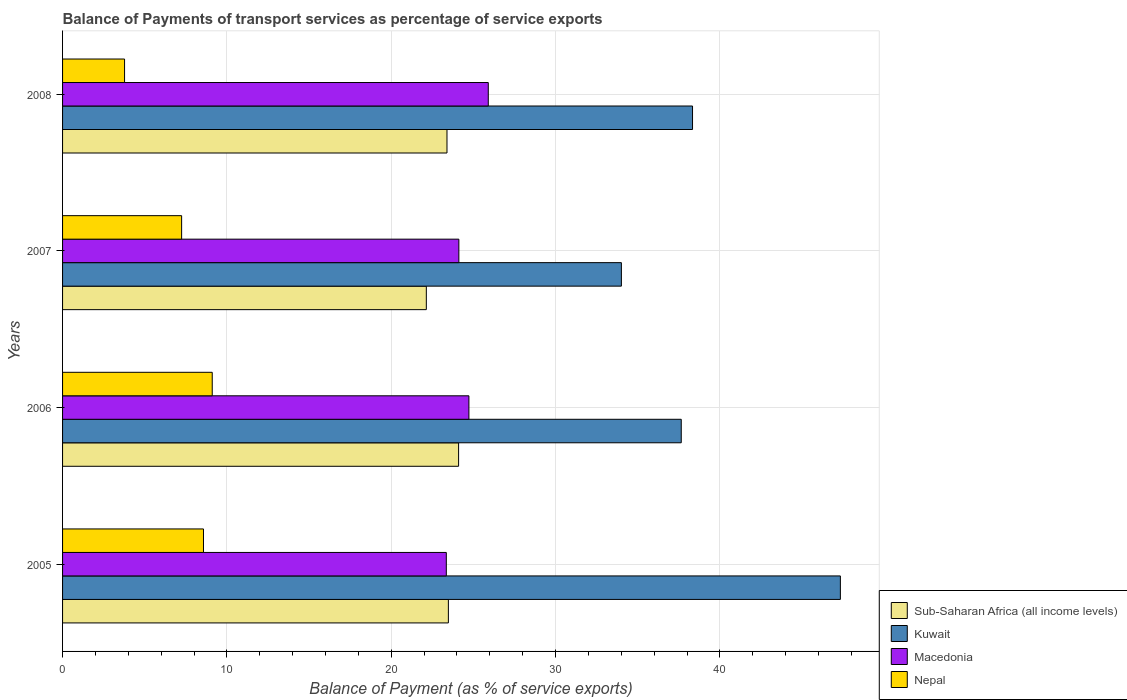How many different coloured bars are there?
Make the answer very short. 4. Are the number of bars per tick equal to the number of legend labels?
Offer a terse response. Yes. Are the number of bars on each tick of the Y-axis equal?
Provide a succinct answer. Yes. How many bars are there on the 4th tick from the top?
Make the answer very short. 4. How many bars are there on the 4th tick from the bottom?
Provide a short and direct response. 4. In how many cases, is the number of bars for a given year not equal to the number of legend labels?
Keep it short and to the point. 0. What is the balance of payments of transport services in Kuwait in 2007?
Ensure brevity in your answer.  34.01. Across all years, what is the maximum balance of payments of transport services in Macedonia?
Offer a very short reply. 25.91. Across all years, what is the minimum balance of payments of transport services in Macedonia?
Your answer should be very brief. 23.35. In which year was the balance of payments of transport services in Macedonia maximum?
Make the answer very short. 2008. What is the total balance of payments of transport services in Sub-Saharan Africa (all income levels) in the graph?
Make the answer very short. 93.1. What is the difference between the balance of payments of transport services in Sub-Saharan Africa (all income levels) in 2006 and that in 2008?
Offer a very short reply. 0.71. What is the difference between the balance of payments of transport services in Kuwait in 2006 and the balance of payments of transport services in Macedonia in 2007?
Offer a terse response. 13.53. What is the average balance of payments of transport services in Kuwait per year?
Make the answer very short. 39.33. In the year 2008, what is the difference between the balance of payments of transport services in Sub-Saharan Africa (all income levels) and balance of payments of transport services in Nepal?
Ensure brevity in your answer.  19.62. What is the ratio of the balance of payments of transport services in Sub-Saharan Africa (all income levels) in 2005 to that in 2006?
Your answer should be compact. 0.97. What is the difference between the highest and the second highest balance of payments of transport services in Kuwait?
Make the answer very short. 9. What is the difference between the highest and the lowest balance of payments of transport services in Sub-Saharan Africa (all income levels)?
Your answer should be very brief. 1.96. Is the sum of the balance of payments of transport services in Nepal in 2005 and 2007 greater than the maximum balance of payments of transport services in Sub-Saharan Africa (all income levels) across all years?
Offer a very short reply. No. What does the 3rd bar from the top in 2007 represents?
Provide a succinct answer. Kuwait. What does the 2nd bar from the bottom in 2008 represents?
Make the answer very short. Kuwait. Is it the case that in every year, the sum of the balance of payments of transport services in Macedonia and balance of payments of transport services in Nepal is greater than the balance of payments of transport services in Sub-Saharan Africa (all income levels)?
Ensure brevity in your answer.  Yes. How many bars are there?
Provide a succinct answer. 16. Are all the bars in the graph horizontal?
Provide a short and direct response. Yes. How many years are there in the graph?
Provide a succinct answer. 4. What is the difference between two consecutive major ticks on the X-axis?
Your answer should be compact. 10. Does the graph contain grids?
Your answer should be very brief. Yes. Where does the legend appear in the graph?
Your answer should be very brief. Bottom right. What is the title of the graph?
Provide a succinct answer. Balance of Payments of transport services as percentage of service exports. Does "Nigeria" appear as one of the legend labels in the graph?
Your answer should be very brief. No. What is the label or title of the X-axis?
Your answer should be very brief. Balance of Payment (as % of service exports). What is the Balance of Payment (as % of service exports) in Sub-Saharan Africa (all income levels) in 2005?
Provide a succinct answer. 23.48. What is the Balance of Payment (as % of service exports) in Kuwait in 2005?
Your answer should be very brief. 47.33. What is the Balance of Payment (as % of service exports) of Macedonia in 2005?
Provide a succinct answer. 23.35. What is the Balance of Payment (as % of service exports) of Nepal in 2005?
Ensure brevity in your answer.  8.58. What is the Balance of Payment (as % of service exports) of Sub-Saharan Africa (all income levels) in 2006?
Ensure brevity in your answer.  24.1. What is the Balance of Payment (as % of service exports) of Kuwait in 2006?
Provide a succinct answer. 37.65. What is the Balance of Payment (as % of service exports) in Macedonia in 2006?
Keep it short and to the point. 24.73. What is the Balance of Payment (as % of service exports) of Nepal in 2006?
Your response must be concise. 9.11. What is the Balance of Payment (as % of service exports) of Sub-Saharan Africa (all income levels) in 2007?
Keep it short and to the point. 22.14. What is the Balance of Payment (as % of service exports) of Kuwait in 2007?
Provide a short and direct response. 34.01. What is the Balance of Payment (as % of service exports) in Macedonia in 2007?
Give a very brief answer. 24.12. What is the Balance of Payment (as % of service exports) in Nepal in 2007?
Offer a terse response. 7.24. What is the Balance of Payment (as % of service exports) of Sub-Saharan Africa (all income levels) in 2008?
Your answer should be compact. 23.39. What is the Balance of Payment (as % of service exports) in Kuwait in 2008?
Make the answer very short. 38.33. What is the Balance of Payment (as % of service exports) in Macedonia in 2008?
Offer a very short reply. 25.91. What is the Balance of Payment (as % of service exports) in Nepal in 2008?
Keep it short and to the point. 3.77. Across all years, what is the maximum Balance of Payment (as % of service exports) in Sub-Saharan Africa (all income levels)?
Offer a terse response. 24.1. Across all years, what is the maximum Balance of Payment (as % of service exports) in Kuwait?
Make the answer very short. 47.33. Across all years, what is the maximum Balance of Payment (as % of service exports) of Macedonia?
Offer a terse response. 25.91. Across all years, what is the maximum Balance of Payment (as % of service exports) in Nepal?
Give a very brief answer. 9.11. Across all years, what is the minimum Balance of Payment (as % of service exports) of Sub-Saharan Africa (all income levels)?
Your answer should be very brief. 22.14. Across all years, what is the minimum Balance of Payment (as % of service exports) in Kuwait?
Offer a terse response. 34.01. Across all years, what is the minimum Balance of Payment (as % of service exports) in Macedonia?
Give a very brief answer. 23.35. Across all years, what is the minimum Balance of Payment (as % of service exports) in Nepal?
Your answer should be compact. 3.77. What is the total Balance of Payment (as % of service exports) of Sub-Saharan Africa (all income levels) in the graph?
Offer a very short reply. 93.11. What is the total Balance of Payment (as % of service exports) of Kuwait in the graph?
Offer a very short reply. 157.32. What is the total Balance of Payment (as % of service exports) in Macedonia in the graph?
Provide a short and direct response. 98.1. What is the total Balance of Payment (as % of service exports) of Nepal in the graph?
Your answer should be compact. 28.7. What is the difference between the Balance of Payment (as % of service exports) of Sub-Saharan Africa (all income levels) in 2005 and that in 2006?
Provide a short and direct response. -0.62. What is the difference between the Balance of Payment (as % of service exports) in Kuwait in 2005 and that in 2006?
Provide a succinct answer. 9.68. What is the difference between the Balance of Payment (as % of service exports) in Macedonia in 2005 and that in 2006?
Keep it short and to the point. -1.38. What is the difference between the Balance of Payment (as % of service exports) in Nepal in 2005 and that in 2006?
Your answer should be very brief. -0.53. What is the difference between the Balance of Payment (as % of service exports) of Sub-Saharan Africa (all income levels) in 2005 and that in 2007?
Offer a very short reply. 1.34. What is the difference between the Balance of Payment (as % of service exports) in Kuwait in 2005 and that in 2007?
Give a very brief answer. 13.33. What is the difference between the Balance of Payment (as % of service exports) in Macedonia in 2005 and that in 2007?
Ensure brevity in your answer.  -0.76. What is the difference between the Balance of Payment (as % of service exports) of Nepal in 2005 and that in 2007?
Offer a very short reply. 1.33. What is the difference between the Balance of Payment (as % of service exports) of Sub-Saharan Africa (all income levels) in 2005 and that in 2008?
Your response must be concise. 0.08. What is the difference between the Balance of Payment (as % of service exports) of Kuwait in 2005 and that in 2008?
Provide a succinct answer. 9. What is the difference between the Balance of Payment (as % of service exports) in Macedonia in 2005 and that in 2008?
Your response must be concise. -2.55. What is the difference between the Balance of Payment (as % of service exports) in Nepal in 2005 and that in 2008?
Keep it short and to the point. 4.8. What is the difference between the Balance of Payment (as % of service exports) in Sub-Saharan Africa (all income levels) in 2006 and that in 2007?
Keep it short and to the point. 1.96. What is the difference between the Balance of Payment (as % of service exports) in Kuwait in 2006 and that in 2007?
Make the answer very short. 3.64. What is the difference between the Balance of Payment (as % of service exports) of Macedonia in 2006 and that in 2007?
Give a very brief answer. 0.61. What is the difference between the Balance of Payment (as % of service exports) in Nepal in 2006 and that in 2007?
Provide a succinct answer. 1.86. What is the difference between the Balance of Payment (as % of service exports) in Sub-Saharan Africa (all income levels) in 2006 and that in 2008?
Provide a succinct answer. 0.71. What is the difference between the Balance of Payment (as % of service exports) in Kuwait in 2006 and that in 2008?
Your answer should be very brief. -0.69. What is the difference between the Balance of Payment (as % of service exports) in Macedonia in 2006 and that in 2008?
Make the answer very short. -1.18. What is the difference between the Balance of Payment (as % of service exports) in Nepal in 2006 and that in 2008?
Your response must be concise. 5.34. What is the difference between the Balance of Payment (as % of service exports) of Sub-Saharan Africa (all income levels) in 2007 and that in 2008?
Provide a succinct answer. -1.26. What is the difference between the Balance of Payment (as % of service exports) of Kuwait in 2007 and that in 2008?
Your response must be concise. -4.33. What is the difference between the Balance of Payment (as % of service exports) in Macedonia in 2007 and that in 2008?
Ensure brevity in your answer.  -1.79. What is the difference between the Balance of Payment (as % of service exports) in Nepal in 2007 and that in 2008?
Your answer should be compact. 3.47. What is the difference between the Balance of Payment (as % of service exports) of Sub-Saharan Africa (all income levels) in 2005 and the Balance of Payment (as % of service exports) of Kuwait in 2006?
Your answer should be compact. -14.17. What is the difference between the Balance of Payment (as % of service exports) of Sub-Saharan Africa (all income levels) in 2005 and the Balance of Payment (as % of service exports) of Macedonia in 2006?
Provide a short and direct response. -1.25. What is the difference between the Balance of Payment (as % of service exports) in Sub-Saharan Africa (all income levels) in 2005 and the Balance of Payment (as % of service exports) in Nepal in 2006?
Your answer should be compact. 14.37. What is the difference between the Balance of Payment (as % of service exports) in Kuwait in 2005 and the Balance of Payment (as % of service exports) in Macedonia in 2006?
Keep it short and to the point. 22.6. What is the difference between the Balance of Payment (as % of service exports) in Kuwait in 2005 and the Balance of Payment (as % of service exports) in Nepal in 2006?
Give a very brief answer. 38.22. What is the difference between the Balance of Payment (as % of service exports) of Macedonia in 2005 and the Balance of Payment (as % of service exports) of Nepal in 2006?
Your answer should be very brief. 14.24. What is the difference between the Balance of Payment (as % of service exports) in Sub-Saharan Africa (all income levels) in 2005 and the Balance of Payment (as % of service exports) in Kuwait in 2007?
Ensure brevity in your answer.  -10.53. What is the difference between the Balance of Payment (as % of service exports) of Sub-Saharan Africa (all income levels) in 2005 and the Balance of Payment (as % of service exports) of Macedonia in 2007?
Provide a short and direct response. -0.64. What is the difference between the Balance of Payment (as % of service exports) in Sub-Saharan Africa (all income levels) in 2005 and the Balance of Payment (as % of service exports) in Nepal in 2007?
Make the answer very short. 16.23. What is the difference between the Balance of Payment (as % of service exports) of Kuwait in 2005 and the Balance of Payment (as % of service exports) of Macedonia in 2007?
Offer a terse response. 23.22. What is the difference between the Balance of Payment (as % of service exports) in Kuwait in 2005 and the Balance of Payment (as % of service exports) in Nepal in 2007?
Offer a terse response. 40.09. What is the difference between the Balance of Payment (as % of service exports) in Macedonia in 2005 and the Balance of Payment (as % of service exports) in Nepal in 2007?
Keep it short and to the point. 16.11. What is the difference between the Balance of Payment (as % of service exports) of Sub-Saharan Africa (all income levels) in 2005 and the Balance of Payment (as % of service exports) of Kuwait in 2008?
Offer a terse response. -14.86. What is the difference between the Balance of Payment (as % of service exports) in Sub-Saharan Africa (all income levels) in 2005 and the Balance of Payment (as % of service exports) in Macedonia in 2008?
Your response must be concise. -2.43. What is the difference between the Balance of Payment (as % of service exports) in Sub-Saharan Africa (all income levels) in 2005 and the Balance of Payment (as % of service exports) in Nepal in 2008?
Keep it short and to the point. 19.7. What is the difference between the Balance of Payment (as % of service exports) of Kuwait in 2005 and the Balance of Payment (as % of service exports) of Macedonia in 2008?
Your response must be concise. 21.43. What is the difference between the Balance of Payment (as % of service exports) of Kuwait in 2005 and the Balance of Payment (as % of service exports) of Nepal in 2008?
Keep it short and to the point. 43.56. What is the difference between the Balance of Payment (as % of service exports) in Macedonia in 2005 and the Balance of Payment (as % of service exports) in Nepal in 2008?
Offer a terse response. 19.58. What is the difference between the Balance of Payment (as % of service exports) of Sub-Saharan Africa (all income levels) in 2006 and the Balance of Payment (as % of service exports) of Kuwait in 2007?
Your answer should be very brief. -9.91. What is the difference between the Balance of Payment (as % of service exports) of Sub-Saharan Africa (all income levels) in 2006 and the Balance of Payment (as % of service exports) of Macedonia in 2007?
Make the answer very short. -0.02. What is the difference between the Balance of Payment (as % of service exports) in Sub-Saharan Africa (all income levels) in 2006 and the Balance of Payment (as % of service exports) in Nepal in 2007?
Your answer should be compact. 16.85. What is the difference between the Balance of Payment (as % of service exports) of Kuwait in 2006 and the Balance of Payment (as % of service exports) of Macedonia in 2007?
Give a very brief answer. 13.53. What is the difference between the Balance of Payment (as % of service exports) in Kuwait in 2006 and the Balance of Payment (as % of service exports) in Nepal in 2007?
Make the answer very short. 30.4. What is the difference between the Balance of Payment (as % of service exports) in Macedonia in 2006 and the Balance of Payment (as % of service exports) in Nepal in 2007?
Offer a terse response. 17.48. What is the difference between the Balance of Payment (as % of service exports) of Sub-Saharan Africa (all income levels) in 2006 and the Balance of Payment (as % of service exports) of Kuwait in 2008?
Your answer should be compact. -14.24. What is the difference between the Balance of Payment (as % of service exports) in Sub-Saharan Africa (all income levels) in 2006 and the Balance of Payment (as % of service exports) in Macedonia in 2008?
Offer a terse response. -1.81. What is the difference between the Balance of Payment (as % of service exports) in Sub-Saharan Africa (all income levels) in 2006 and the Balance of Payment (as % of service exports) in Nepal in 2008?
Offer a very short reply. 20.33. What is the difference between the Balance of Payment (as % of service exports) of Kuwait in 2006 and the Balance of Payment (as % of service exports) of Macedonia in 2008?
Give a very brief answer. 11.74. What is the difference between the Balance of Payment (as % of service exports) in Kuwait in 2006 and the Balance of Payment (as % of service exports) in Nepal in 2008?
Your answer should be compact. 33.88. What is the difference between the Balance of Payment (as % of service exports) in Macedonia in 2006 and the Balance of Payment (as % of service exports) in Nepal in 2008?
Give a very brief answer. 20.95. What is the difference between the Balance of Payment (as % of service exports) in Sub-Saharan Africa (all income levels) in 2007 and the Balance of Payment (as % of service exports) in Kuwait in 2008?
Provide a succinct answer. -16.2. What is the difference between the Balance of Payment (as % of service exports) of Sub-Saharan Africa (all income levels) in 2007 and the Balance of Payment (as % of service exports) of Macedonia in 2008?
Provide a short and direct response. -3.77. What is the difference between the Balance of Payment (as % of service exports) of Sub-Saharan Africa (all income levels) in 2007 and the Balance of Payment (as % of service exports) of Nepal in 2008?
Offer a very short reply. 18.36. What is the difference between the Balance of Payment (as % of service exports) of Kuwait in 2007 and the Balance of Payment (as % of service exports) of Macedonia in 2008?
Keep it short and to the point. 8.1. What is the difference between the Balance of Payment (as % of service exports) of Kuwait in 2007 and the Balance of Payment (as % of service exports) of Nepal in 2008?
Keep it short and to the point. 30.23. What is the difference between the Balance of Payment (as % of service exports) in Macedonia in 2007 and the Balance of Payment (as % of service exports) in Nepal in 2008?
Your answer should be compact. 20.34. What is the average Balance of Payment (as % of service exports) in Sub-Saharan Africa (all income levels) per year?
Make the answer very short. 23.28. What is the average Balance of Payment (as % of service exports) of Kuwait per year?
Offer a terse response. 39.33. What is the average Balance of Payment (as % of service exports) in Macedonia per year?
Ensure brevity in your answer.  24.52. What is the average Balance of Payment (as % of service exports) in Nepal per year?
Make the answer very short. 7.18. In the year 2005, what is the difference between the Balance of Payment (as % of service exports) in Sub-Saharan Africa (all income levels) and Balance of Payment (as % of service exports) in Kuwait?
Ensure brevity in your answer.  -23.85. In the year 2005, what is the difference between the Balance of Payment (as % of service exports) in Sub-Saharan Africa (all income levels) and Balance of Payment (as % of service exports) in Macedonia?
Provide a succinct answer. 0.13. In the year 2005, what is the difference between the Balance of Payment (as % of service exports) of Sub-Saharan Africa (all income levels) and Balance of Payment (as % of service exports) of Nepal?
Provide a short and direct response. 14.9. In the year 2005, what is the difference between the Balance of Payment (as % of service exports) in Kuwait and Balance of Payment (as % of service exports) in Macedonia?
Ensure brevity in your answer.  23.98. In the year 2005, what is the difference between the Balance of Payment (as % of service exports) of Kuwait and Balance of Payment (as % of service exports) of Nepal?
Offer a very short reply. 38.76. In the year 2005, what is the difference between the Balance of Payment (as % of service exports) in Macedonia and Balance of Payment (as % of service exports) in Nepal?
Provide a succinct answer. 14.78. In the year 2006, what is the difference between the Balance of Payment (as % of service exports) of Sub-Saharan Africa (all income levels) and Balance of Payment (as % of service exports) of Kuwait?
Your answer should be very brief. -13.55. In the year 2006, what is the difference between the Balance of Payment (as % of service exports) of Sub-Saharan Africa (all income levels) and Balance of Payment (as % of service exports) of Macedonia?
Ensure brevity in your answer.  -0.63. In the year 2006, what is the difference between the Balance of Payment (as % of service exports) in Sub-Saharan Africa (all income levels) and Balance of Payment (as % of service exports) in Nepal?
Ensure brevity in your answer.  14.99. In the year 2006, what is the difference between the Balance of Payment (as % of service exports) of Kuwait and Balance of Payment (as % of service exports) of Macedonia?
Make the answer very short. 12.92. In the year 2006, what is the difference between the Balance of Payment (as % of service exports) of Kuwait and Balance of Payment (as % of service exports) of Nepal?
Offer a terse response. 28.54. In the year 2006, what is the difference between the Balance of Payment (as % of service exports) of Macedonia and Balance of Payment (as % of service exports) of Nepal?
Give a very brief answer. 15.62. In the year 2007, what is the difference between the Balance of Payment (as % of service exports) of Sub-Saharan Africa (all income levels) and Balance of Payment (as % of service exports) of Kuwait?
Your answer should be very brief. -11.87. In the year 2007, what is the difference between the Balance of Payment (as % of service exports) in Sub-Saharan Africa (all income levels) and Balance of Payment (as % of service exports) in Macedonia?
Make the answer very short. -1.98. In the year 2007, what is the difference between the Balance of Payment (as % of service exports) of Sub-Saharan Africa (all income levels) and Balance of Payment (as % of service exports) of Nepal?
Offer a terse response. 14.89. In the year 2007, what is the difference between the Balance of Payment (as % of service exports) of Kuwait and Balance of Payment (as % of service exports) of Macedonia?
Ensure brevity in your answer.  9.89. In the year 2007, what is the difference between the Balance of Payment (as % of service exports) in Kuwait and Balance of Payment (as % of service exports) in Nepal?
Keep it short and to the point. 26.76. In the year 2007, what is the difference between the Balance of Payment (as % of service exports) in Macedonia and Balance of Payment (as % of service exports) in Nepal?
Offer a very short reply. 16.87. In the year 2008, what is the difference between the Balance of Payment (as % of service exports) of Sub-Saharan Africa (all income levels) and Balance of Payment (as % of service exports) of Kuwait?
Your answer should be very brief. -14.94. In the year 2008, what is the difference between the Balance of Payment (as % of service exports) of Sub-Saharan Africa (all income levels) and Balance of Payment (as % of service exports) of Macedonia?
Offer a terse response. -2.51. In the year 2008, what is the difference between the Balance of Payment (as % of service exports) of Sub-Saharan Africa (all income levels) and Balance of Payment (as % of service exports) of Nepal?
Your answer should be very brief. 19.62. In the year 2008, what is the difference between the Balance of Payment (as % of service exports) of Kuwait and Balance of Payment (as % of service exports) of Macedonia?
Make the answer very short. 12.43. In the year 2008, what is the difference between the Balance of Payment (as % of service exports) of Kuwait and Balance of Payment (as % of service exports) of Nepal?
Offer a very short reply. 34.56. In the year 2008, what is the difference between the Balance of Payment (as % of service exports) of Macedonia and Balance of Payment (as % of service exports) of Nepal?
Your answer should be very brief. 22.13. What is the ratio of the Balance of Payment (as % of service exports) of Sub-Saharan Africa (all income levels) in 2005 to that in 2006?
Provide a succinct answer. 0.97. What is the ratio of the Balance of Payment (as % of service exports) in Kuwait in 2005 to that in 2006?
Your response must be concise. 1.26. What is the ratio of the Balance of Payment (as % of service exports) in Macedonia in 2005 to that in 2006?
Ensure brevity in your answer.  0.94. What is the ratio of the Balance of Payment (as % of service exports) of Nepal in 2005 to that in 2006?
Provide a short and direct response. 0.94. What is the ratio of the Balance of Payment (as % of service exports) of Sub-Saharan Africa (all income levels) in 2005 to that in 2007?
Your answer should be very brief. 1.06. What is the ratio of the Balance of Payment (as % of service exports) of Kuwait in 2005 to that in 2007?
Your answer should be compact. 1.39. What is the ratio of the Balance of Payment (as % of service exports) of Macedonia in 2005 to that in 2007?
Offer a terse response. 0.97. What is the ratio of the Balance of Payment (as % of service exports) of Nepal in 2005 to that in 2007?
Make the answer very short. 1.18. What is the ratio of the Balance of Payment (as % of service exports) in Kuwait in 2005 to that in 2008?
Make the answer very short. 1.23. What is the ratio of the Balance of Payment (as % of service exports) in Macedonia in 2005 to that in 2008?
Your response must be concise. 0.9. What is the ratio of the Balance of Payment (as % of service exports) of Nepal in 2005 to that in 2008?
Your response must be concise. 2.27. What is the ratio of the Balance of Payment (as % of service exports) of Sub-Saharan Africa (all income levels) in 2006 to that in 2007?
Give a very brief answer. 1.09. What is the ratio of the Balance of Payment (as % of service exports) of Kuwait in 2006 to that in 2007?
Ensure brevity in your answer.  1.11. What is the ratio of the Balance of Payment (as % of service exports) in Macedonia in 2006 to that in 2007?
Your answer should be compact. 1.03. What is the ratio of the Balance of Payment (as % of service exports) in Nepal in 2006 to that in 2007?
Your response must be concise. 1.26. What is the ratio of the Balance of Payment (as % of service exports) in Sub-Saharan Africa (all income levels) in 2006 to that in 2008?
Provide a succinct answer. 1.03. What is the ratio of the Balance of Payment (as % of service exports) of Kuwait in 2006 to that in 2008?
Offer a terse response. 0.98. What is the ratio of the Balance of Payment (as % of service exports) of Macedonia in 2006 to that in 2008?
Your answer should be very brief. 0.95. What is the ratio of the Balance of Payment (as % of service exports) in Nepal in 2006 to that in 2008?
Keep it short and to the point. 2.41. What is the ratio of the Balance of Payment (as % of service exports) in Sub-Saharan Africa (all income levels) in 2007 to that in 2008?
Provide a short and direct response. 0.95. What is the ratio of the Balance of Payment (as % of service exports) of Kuwait in 2007 to that in 2008?
Your response must be concise. 0.89. What is the ratio of the Balance of Payment (as % of service exports) in Macedonia in 2007 to that in 2008?
Keep it short and to the point. 0.93. What is the ratio of the Balance of Payment (as % of service exports) of Nepal in 2007 to that in 2008?
Your answer should be very brief. 1.92. What is the difference between the highest and the second highest Balance of Payment (as % of service exports) of Sub-Saharan Africa (all income levels)?
Offer a terse response. 0.62. What is the difference between the highest and the second highest Balance of Payment (as % of service exports) in Kuwait?
Keep it short and to the point. 9. What is the difference between the highest and the second highest Balance of Payment (as % of service exports) of Macedonia?
Your response must be concise. 1.18. What is the difference between the highest and the second highest Balance of Payment (as % of service exports) of Nepal?
Provide a succinct answer. 0.53. What is the difference between the highest and the lowest Balance of Payment (as % of service exports) in Sub-Saharan Africa (all income levels)?
Provide a short and direct response. 1.96. What is the difference between the highest and the lowest Balance of Payment (as % of service exports) of Kuwait?
Provide a succinct answer. 13.33. What is the difference between the highest and the lowest Balance of Payment (as % of service exports) in Macedonia?
Your answer should be very brief. 2.55. What is the difference between the highest and the lowest Balance of Payment (as % of service exports) in Nepal?
Keep it short and to the point. 5.34. 